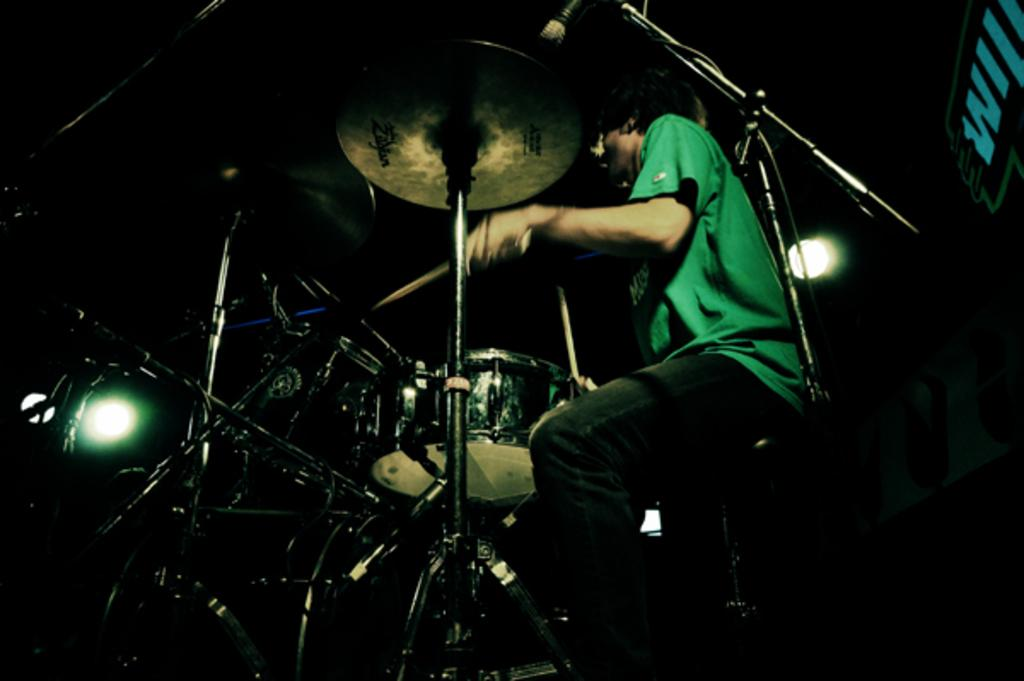What is the main subject of the image? The main subject of the image is a person. What is the person doing in the image? The person is playing musical instruments. How many lights can be seen in the image? There is no mention of lights in the image; the main focus is on the person playing musical instruments. 